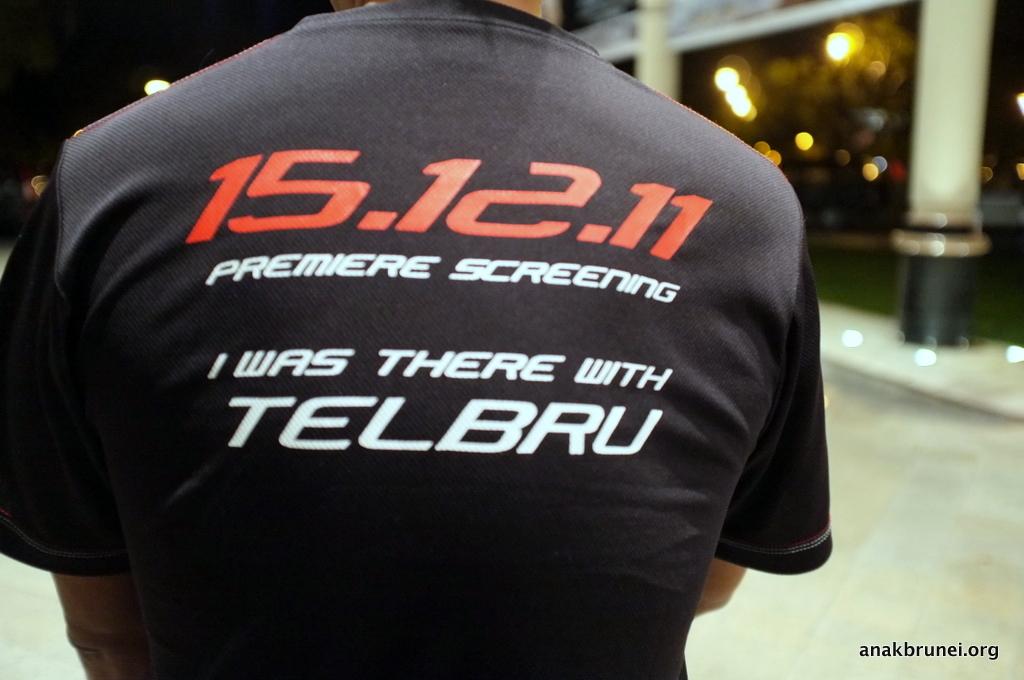Who was there with telbru?
Your answer should be very brief. I. 